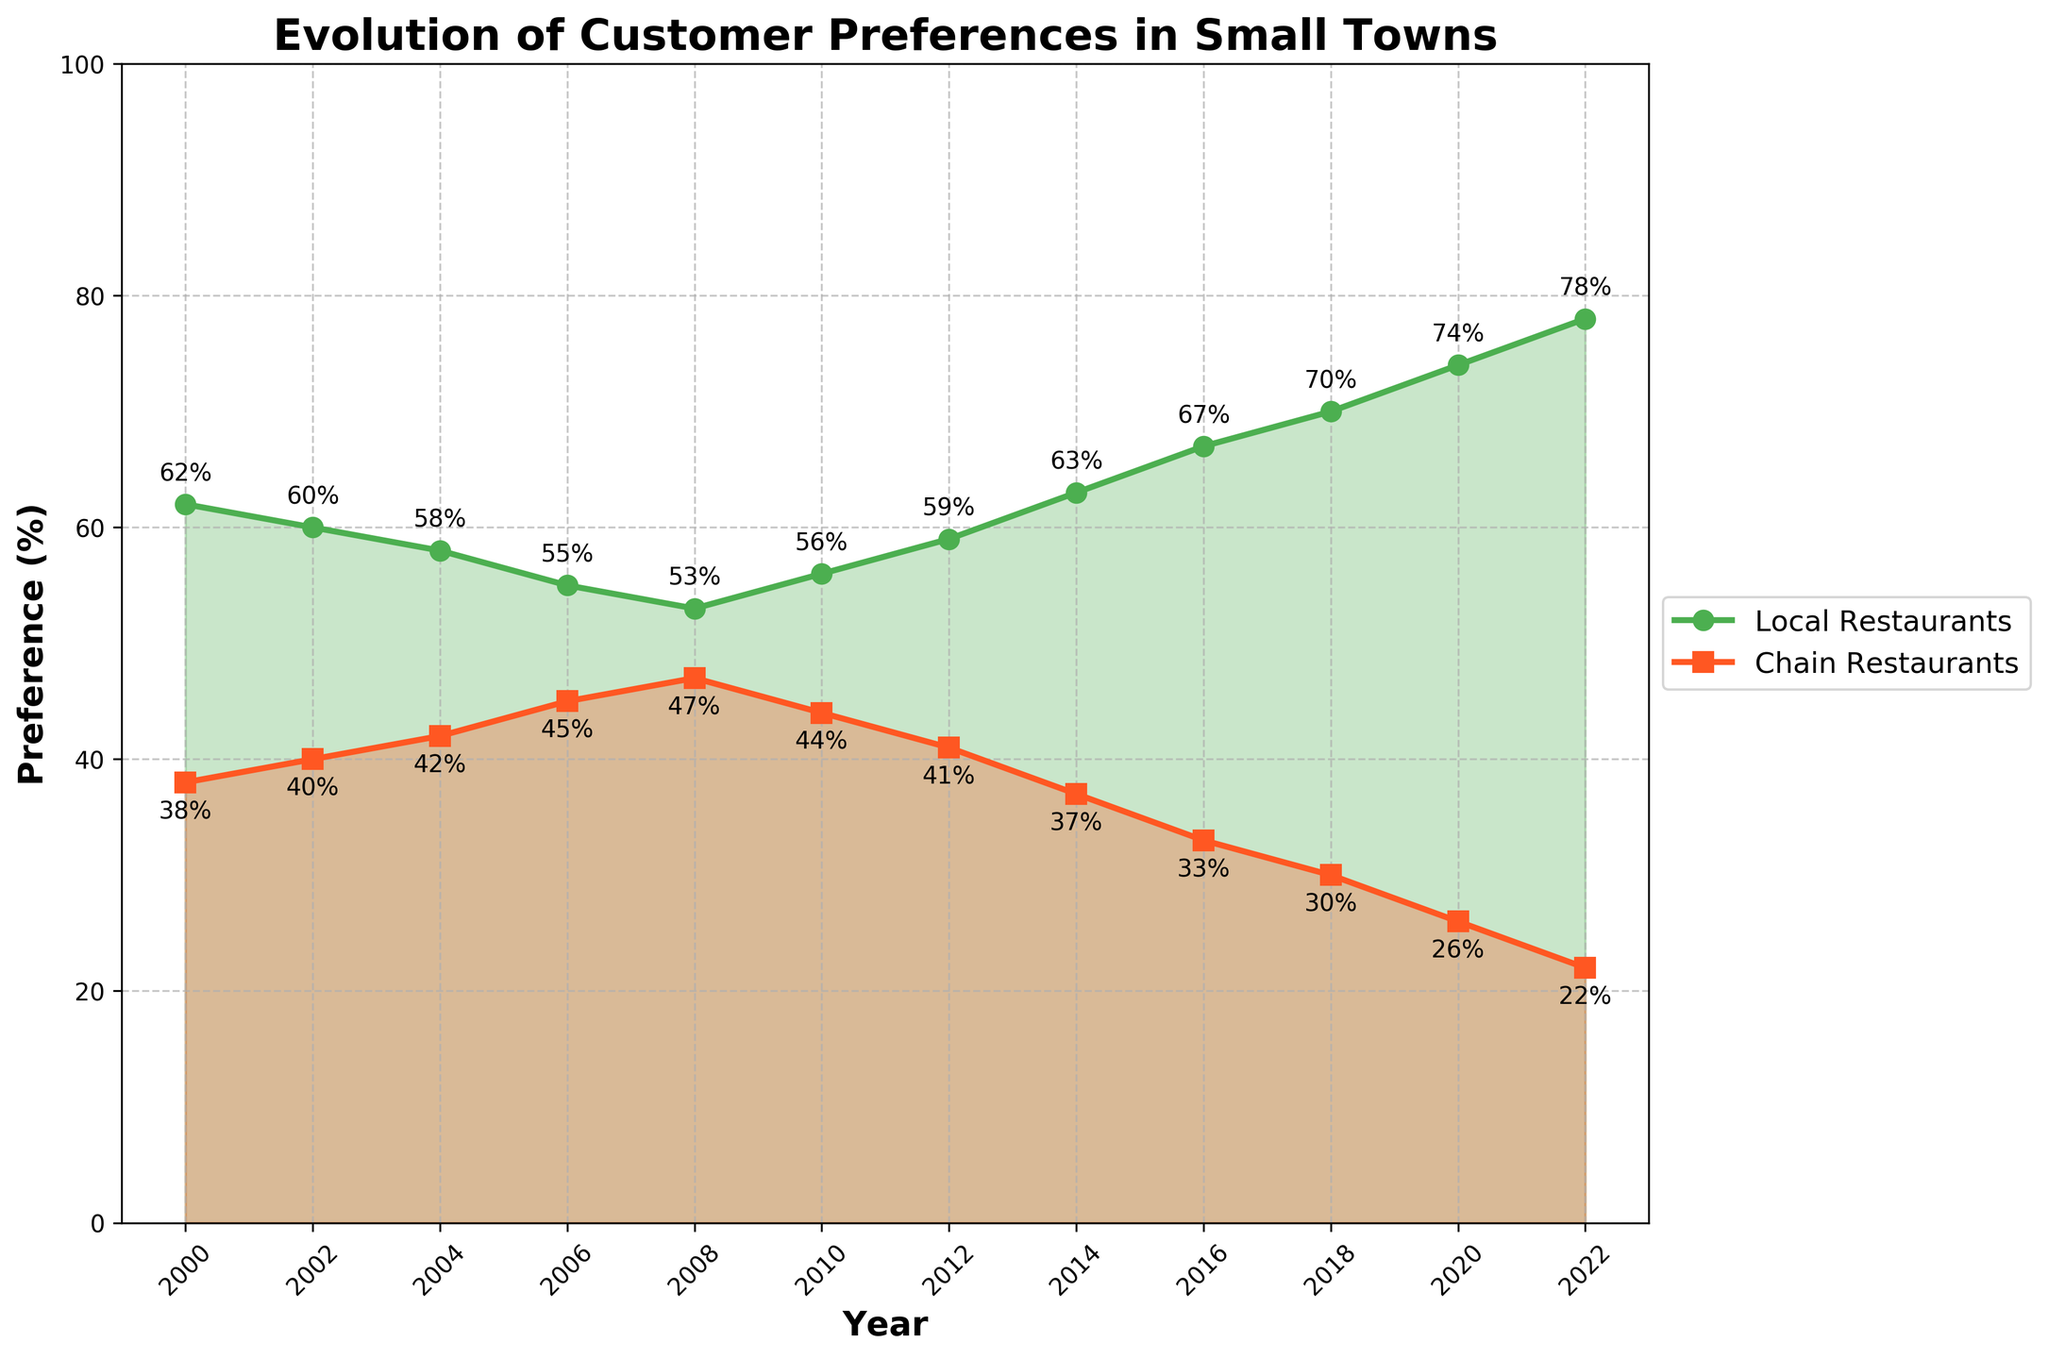What year had the highest preference for local restaurants? The highest preference for local restaurants is marked by the peak value on the green line. The peak value appears at 78% in the year 2022.
Answer: 2022 During which year was the preference for chain restaurants the lowest? The lowest preference for chain restaurants can be identified by the lowest point on the red line, which is 22% in 2022.
Answer: 2022 What is the difference in preference for local restaurants between 2000 and 2022? In 2000, the preference for local restaurants was 62%. In 2022, it was 78%. The difference is 78% - 62% = 16%.
Answer: 16% How many years did it take for local restaurant preference to increase from 55% to 74%? Local restaurant preference was 55% in 2006 and 74% in 2020. Therefore, it took 2020 - 2006 = 14 years.
Answer: 14 years What is the average preference for local restaurants in the years 2000, 2010, and 2020? List the preferences for these years: 62% (2000), 56% (2010), and 74% (2020). Calculate the average: (62 + 56 + 74) / 3 = 64%.
Answer: 64% Between 2010 and 2016, which type of restaurant saw a greater percentage increase in preference? For local restaurants, the preference increased from 56% in 2010 to 67% in 2016, an increase of 67 - 56 = 11%. For chain restaurants, the preference decreased from 44% in 2010 to 33% in 2016, a decrease of 44 - 33 = 11%. Both increases are quantitatively equal.
Answer: Same What can you infer from the colors of the lines representing local and chain restaurant preferences? Green represents local restaurants and red represents chain restaurants, signifying a visual comparison between the two types with their respective preferences over time.
Answer: Local: Green, Chain: Red Which period saw the most significant increase in preference for local restaurants? The period showing the most rapid increase in the green line can be observed between 2018 (70%) and 2022 (78%), which is an increase of 8%.
Answer: 2018-2022 In which year were the local and chain restaurant preferences closest to each other? The lines intersect or nearly intersect around the year 2008 where local restaurant preferences were 53% and chain restaurant preferences were 47%, a difference of 6%.
Answer: 2008 What successive years show a switch from decreasing to increasing preference for local restaurants? The local restaurant preference decreased from 2008 (53%) to 2010 (56%) but started to increase again from 2010 (56%) to 2012 (59%).
Answer: 2010-2012 